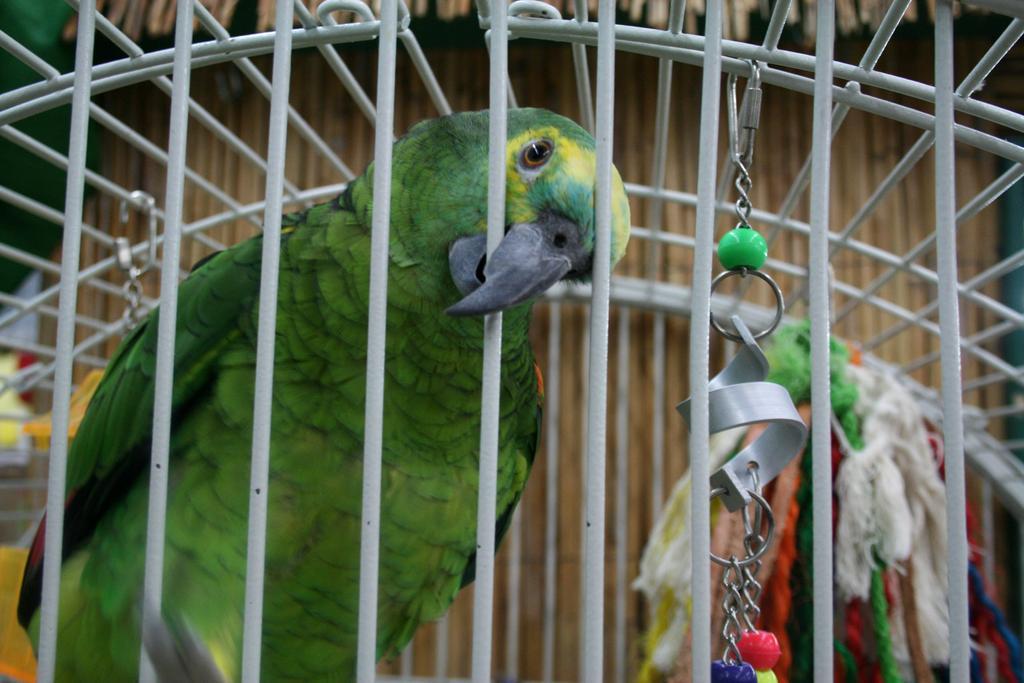Describe this image in one or two sentences. In this image we can see a parrot in the cage. 